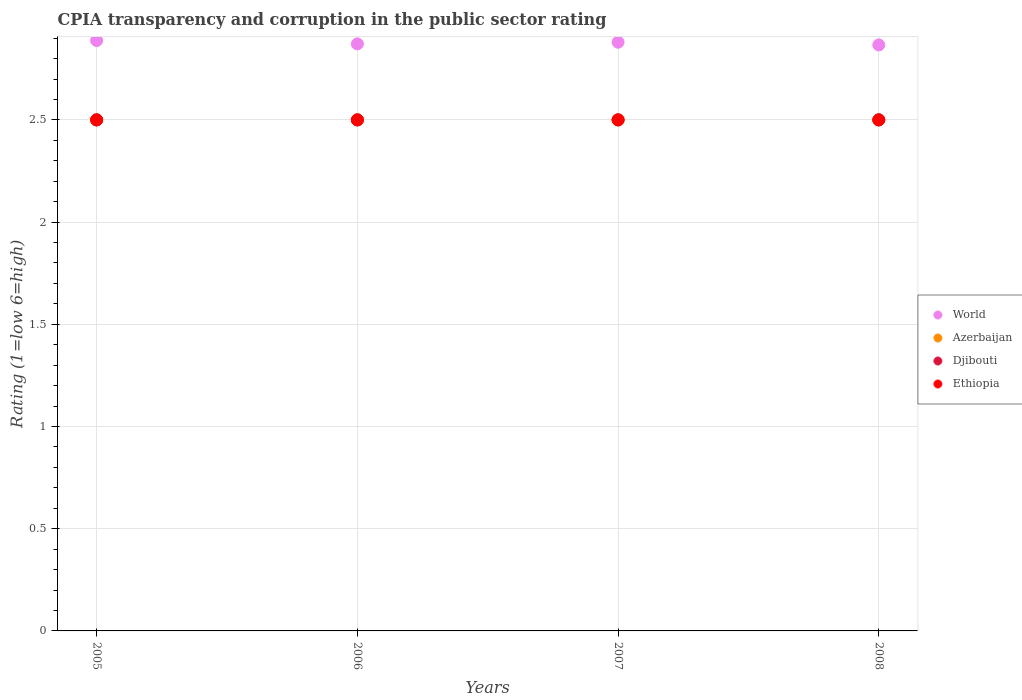How many different coloured dotlines are there?
Keep it short and to the point. 4. Is the number of dotlines equal to the number of legend labels?
Offer a terse response. Yes. What is the CPIA rating in Azerbaijan in 2006?
Your answer should be compact. 2.5. Across all years, what is the minimum CPIA rating in Ethiopia?
Provide a succinct answer. 2.5. In which year was the CPIA rating in Djibouti maximum?
Ensure brevity in your answer.  2005. What is the total CPIA rating in World in the graph?
Provide a short and direct response. 11.51. What is the difference between the CPIA rating in Djibouti in 2005 and that in 2007?
Provide a succinct answer. 0. What is the difference between the CPIA rating in Djibouti in 2005 and the CPIA rating in Ethiopia in 2008?
Offer a very short reply. 0. What is the average CPIA rating in Djibouti per year?
Your response must be concise. 2.5. In the year 2007, what is the difference between the CPIA rating in Ethiopia and CPIA rating in Azerbaijan?
Provide a short and direct response. 0. In how many years, is the CPIA rating in Djibouti greater than 1.6?
Make the answer very short. 4. What is the ratio of the CPIA rating in World in 2005 to that in 2008?
Your response must be concise. 1.01. Is the CPIA rating in World in 2007 less than that in 2008?
Make the answer very short. No. Is the difference between the CPIA rating in Ethiopia in 2006 and 2007 greater than the difference between the CPIA rating in Azerbaijan in 2006 and 2007?
Ensure brevity in your answer.  No. What is the difference between the highest and the lowest CPIA rating in Azerbaijan?
Ensure brevity in your answer.  0. In how many years, is the CPIA rating in World greater than the average CPIA rating in World taken over all years?
Provide a short and direct response. 2. Is the sum of the CPIA rating in Ethiopia in 2007 and 2008 greater than the maximum CPIA rating in World across all years?
Your answer should be very brief. Yes. Is it the case that in every year, the sum of the CPIA rating in Azerbaijan and CPIA rating in World  is greater than the sum of CPIA rating in Ethiopia and CPIA rating in Djibouti?
Your answer should be very brief. Yes. Is it the case that in every year, the sum of the CPIA rating in Azerbaijan and CPIA rating in Ethiopia  is greater than the CPIA rating in Djibouti?
Provide a succinct answer. Yes. Is the CPIA rating in Djibouti strictly less than the CPIA rating in Azerbaijan over the years?
Provide a short and direct response. No. How many dotlines are there?
Keep it short and to the point. 4. Are the values on the major ticks of Y-axis written in scientific E-notation?
Offer a terse response. No. Where does the legend appear in the graph?
Your answer should be compact. Center right. How many legend labels are there?
Offer a terse response. 4. How are the legend labels stacked?
Make the answer very short. Vertical. What is the title of the graph?
Offer a terse response. CPIA transparency and corruption in the public sector rating. Does "Cambodia" appear as one of the legend labels in the graph?
Your response must be concise. No. What is the Rating (1=low 6=high) of World in 2005?
Your answer should be compact. 2.89. What is the Rating (1=low 6=high) in Ethiopia in 2005?
Keep it short and to the point. 2.5. What is the Rating (1=low 6=high) of World in 2006?
Your answer should be compact. 2.87. What is the Rating (1=low 6=high) in Ethiopia in 2006?
Your answer should be compact. 2.5. What is the Rating (1=low 6=high) of World in 2007?
Make the answer very short. 2.88. What is the Rating (1=low 6=high) of Azerbaijan in 2007?
Your response must be concise. 2.5. What is the Rating (1=low 6=high) of Djibouti in 2007?
Your response must be concise. 2.5. What is the Rating (1=low 6=high) of Ethiopia in 2007?
Offer a terse response. 2.5. What is the Rating (1=low 6=high) of World in 2008?
Your answer should be very brief. 2.87. What is the Rating (1=low 6=high) of Azerbaijan in 2008?
Keep it short and to the point. 2.5. Across all years, what is the maximum Rating (1=low 6=high) of World?
Provide a succinct answer. 2.89. Across all years, what is the maximum Rating (1=low 6=high) of Djibouti?
Your response must be concise. 2.5. Across all years, what is the minimum Rating (1=low 6=high) in World?
Ensure brevity in your answer.  2.87. Across all years, what is the minimum Rating (1=low 6=high) in Ethiopia?
Ensure brevity in your answer.  2.5. What is the total Rating (1=low 6=high) of World in the graph?
Offer a terse response. 11.51. What is the total Rating (1=low 6=high) of Ethiopia in the graph?
Keep it short and to the point. 10. What is the difference between the Rating (1=low 6=high) in World in 2005 and that in 2006?
Ensure brevity in your answer.  0.02. What is the difference between the Rating (1=low 6=high) in Ethiopia in 2005 and that in 2006?
Keep it short and to the point. 0. What is the difference between the Rating (1=low 6=high) of World in 2005 and that in 2007?
Make the answer very short. 0.01. What is the difference between the Rating (1=low 6=high) in Azerbaijan in 2005 and that in 2007?
Your response must be concise. 0. What is the difference between the Rating (1=low 6=high) in World in 2005 and that in 2008?
Keep it short and to the point. 0.02. What is the difference between the Rating (1=low 6=high) of World in 2006 and that in 2007?
Give a very brief answer. -0.01. What is the difference between the Rating (1=low 6=high) of Azerbaijan in 2006 and that in 2007?
Keep it short and to the point. 0. What is the difference between the Rating (1=low 6=high) in Djibouti in 2006 and that in 2007?
Give a very brief answer. 0. What is the difference between the Rating (1=low 6=high) in World in 2006 and that in 2008?
Provide a succinct answer. 0.01. What is the difference between the Rating (1=low 6=high) in World in 2007 and that in 2008?
Ensure brevity in your answer.  0.01. What is the difference between the Rating (1=low 6=high) in Ethiopia in 2007 and that in 2008?
Make the answer very short. 0. What is the difference between the Rating (1=low 6=high) in World in 2005 and the Rating (1=low 6=high) in Azerbaijan in 2006?
Offer a terse response. 0.39. What is the difference between the Rating (1=low 6=high) of World in 2005 and the Rating (1=low 6=high) of Djibouti in 2006?
Your answer should be compact. 0.39. What is the difference between the Rating (1=low 6=high) of World in 2005 and the Rating (1=low 6=high) of Ethiopia in 2006?
Your answer should be very brief. 0.39. What is the difference between the Rating (1=low 6=high) of Azerbaijan in 2005 and the Rating (1=low 6=high) of Djibouti in 2006?
Provide a succinct answer. 0. What is the difference between the Rating (1=low 6=high) of Azerbaijan in 2005 and the Rating (1=low 6=high) of Ethiopia in 2006?
Keep it short and to the point. 0. What is the difference between the Rating (1=low 6=high) of World in 2005 and the Rating (1=low 6=high) of Azerbaijan in 2007?
Provide a short and direct response. 0.39. What is the difference between the Rating (1=low 6=high) in World in 2005 and the Rating (1=low 6=high) in Djibouti in 2007?
Keep it short and to the point. 0.39. What is the difference between the Rating (1=low 6=high) in World in 2005 and the Rating (1=low 6=high) in Ethiopia in 2007?
Offer a very short reply. 0.39. What is the difference between the Rating (1=low 6=high) in Djibouti in 2005 and the Rating (1=low 6=high) in Ethiopia in 2007?
Offer a terse response. 0. What is the difference between the Rating (1=low 6=high) in World in 2005 and the Rating (1=low 6=high) in Azerbaijan in 2008?
Provide a succinct answer. 0.39. What is the difference between the Rating (1=low 6=high) in World in 2005 and the Rating (1=low 6=high) in Djibouti in 2008?
Offer a terse response. 0.39. What is the difference between the Rating (1=low 6=high) of World in 2005 and the Rating (1=low 6=high) of Ethiopia in 2008?
Ensure brevity in your answer.  0.39. What is the difference between the Rating (1=low 6=high) in Azerbaijan in 2005 and the Rating (1=low 6=high) in Ethiopia in 2008?
Provide a succinct answer. 0. What is the difference between the Rating (1=low 6=high) in World in 2006 and the Rating (1=low 6=high) in Azerbaijan in 2007?
Provide a succinct answer. 0.37. What is the difference between the Rating (1=low 6=high) of World in 2006 and the Rating (1=low 6=high) of Djibouti in 2007?
Ensure brevity in your answer.  0.37. What is the difference between the Rating (1=low 6=high) in World in 2006 and the Rating (1=low 6=high) in Ethiopia in 2007?
Keep it short and to the point. 0.37. What is the difference between the Rating (1=low 6=high) of World in 2006 and the Rating (1=low 6=high) of Azerbaijan in 2008?
Make the answer very short. 0.37. What is the difference between the Rating (1=low 6=high) in World in 2006 and the Rating (1=low 6=high) in Djibouti in 2008?
Your response must be concise. 0.37. What is the difference between the Rating (1=low 6=high) in World in 2006 and the Rating (1=low 6=high) in Ethiopia in 2008?
Offer a terse response. 0.37. What is the difference between the Rating (1=low 6=high) in Azerbaijan in 2006 and the Rating (1=low 6=high) in Djibouti in 2008?
Offer a terse response. 0. What is the difference between the Rating (1=low 6=high) of Djibouti in 2006 and the Rating (1=low 6=high) of Ethiopia in 2008?
Your answer should be compact. 0. What is the difference between the Rating (1=low 6=high) of World in 2007 and the Rating (1=low 6=high) of Azerbaijan in 2008?
Make the answer very short. 0.38. What is the difference between the Rating (1=low 6=high) of World in 2007 and the Rating (1=low 6=high) of Djibouti in 2008?
Ensure brevity in your answer.  0.38. What is the difference between the Rating (1=low 6=high) in World in 2007 and the Rating (1=low 6=high) in Ethiopia in 2008?
Give a very brief answer. 0.38. What is the difference between the Rating (1=low 6=high) in Azerbaijan in 2007 and the Rating (1=low 6=high) in Djibouti in 2008?
Provide a succinct answer. 0. What is the difference between the Rating (1=low 6=high) of Djibouti in 2007 and the Rating (1=low 6=high) of Ethiopia in 2008?
Make the answer very short. 0. What is the average Rating (1=low 6=high) in World per year?
Keep it short and to the point. 2.88. What is the average Rating (1=low 6=high) in Azerbaijan per year?
Keep it short and to the point. 2.5. What is the average Rating (1=low 6=high) of Djibouti per year?
Your answer should be compact. 2.5. What is the average Rating (1=low 6=high) in Ethiopia per year?
Give a very brief answer. 2.5. In the year 2005, what is the difference between the Rating (1=low 6=high) of World and Rating (1=low 6=high) of Azerbaijan?
Ensure brevity in your answer.  0.39. In the year 2005, what is the difference between the Rating (1=low 6=high) of World and Rating (1=low 6=high) of Djibouti?
Offer a very short reply. 0.39. In the year 2005, what is the difference between the Rating (1=low 6=high) of World and Rating (1=low 6=high) of Ethiopia?
Provide a short and direct response. 0.39. In the year 2005, what is the difference between the Rating (1=low 6=high) of Azerbaijan and Rating (1=low 6=high) of Djibouti?
Keep it short and to the point. 0. In the year 2005, what is the difference between the Rating (1=low 6=high) in Azerbaijan and Rating (1=low 6=high) in Ethiopia?
Provide a succinct answer. 0. In the year 2006, what is the difference between the Rating (1=low 6=high) of World and Rating (1=low 6=high) of Azerbaijan?
Make the answer very short. 0.37. In the year 2006, what is the difference between the Rating (1=low 6=high) in World and Rating (1=low 6=high) in Djibouti?
Your answer should be compact. 0.37. In the year 2006, what is the difference between the Rating (1=low 6=high) in World and Rating (1=low 6=high) in Ethiopia?
Your answer should be compact. 0.37. In the year 2006, what is the difference between the Rating (1=low 6=high) in Djibouti and Rating (1=low 6=high) in Ethiopia?
Offer a terse response. 0. In the year 2007, what is the difference between the Rating (1=low 6=high) in World and Rating (1=low 6=high) in Azerbaijan?
Offer a terse response. 0.38. In the year 2007, what is the difference between the Rating (1=low 6=high) in World and Rating (1=low 6=high) in Djibouti?
Provide a succinct answer. 0.38. In the year 2007, what is the difference between the Rating (1=low 6=high) in World and Rating (1=low 6=high) in Ethiopia?
Your response must be concise. 0.38. In the year 2007, what is the difference between the Rating (1=low 6=high) in Djibouti and Rating (1=low 6=high) in Ethiopia?
Offer a very short reply. 0. In the year 2008, what is the difference between the Rating (1=low 6=high) of World and Rating (1=low 6=high) of Azerbaijan?
Your response must be concise. 0.37. In the year 2008, what is the difference between the Rating (1=low 6=high) in World and Rating (1=low 6=high) in Djibouti?
Your answer should be compact. 0.37. In the year 2008, what is the difference between the Rating (1=low 6=high) of World and Rating (1=low 6=high) of Ethiopia?
Ensure brevity in your answer.  0.37. In the year 2008, what is the difference between the Rating (1=low 6=high) of Azerbaijan and Rating (1=low 6=high) of Djibouti?
Give a very brief answer. 0. In the year 2008, what is the difference between the Rating (1=low 6=high) of Azerbaijan and Rating (1=low 6=high) of Ethiopia?
Provide a succinct answer. 0. What is the ratio of the Rating (1=low 6=high) of Azerbaijan in 2005 to that in 2006?
Keep it short and to the point. 1. What is the ratio of the Rating (1=low 6=high) in Djibouti in 2005 to that in 2006?
Keep it short and to the point. 1. What is the ratio of the Rating (1=low 6=high) in Ethiopia in 2005 to that in 2006?
Make the answer very short. 1. What is the ratio of the Rating (1=low 6=high) in Djibouti in 2005 to that in 2007?
Ensure brevity in your answer.  1. What is the ratio of the Rating (1=low 6=high) of World in 2005 to that in 2008?
Make the answer very short. 1.01. What is the ratio of the Rating (1=low 6=high) of Djibouti in 2005 to that in 2008?
Your response must be concise. 1. What is the ratio of the Rating (1=low 6=high) of World in 2006 to that in 2007?
Offer a very short reply. 1. What is the ratio of the Rating (1=low 6=high) in Azerbaijan in 2006 to that in 2007?
Your answer should be compact. 1. What is the ratio of the Rating (1=low 6=high) in Djibouti in 2006 to that in 2007?
Your answer should be compact. 1. What is the ratio of the Rating (1=low 6=high) of World in 2007 to that in 2008?
Ensure brevity in your answer.  1. What is the ratio of the Rating (1=low 6=high) in Azerbaijan in 2007 to that in 2008?
Provide a succinct answer. 1. What is the difference between the highest and the second highest Rating (1=low 6=high) of World?
Make the answer very short. 0.01. What is the difference between the highest and the second highest Rating (1=low 6=high) in Azerbaijan?
Provide a short and direct response. 0. What is the difference between the highest and the second highest Rating (1=low 6=high) in Ethiopia?
Give a very brief answer. 0. What is the difference between the highest and the lowest Rating (1=low 6=high) of World?
Offer a very short reply. 0.02. What is the difference between the highest and the lowest Rating (1=low 6=high) in Azerbaijan?
Give a very brief answer. 0. What is the difference between the highest and the lowest Rating (1=low 6=high) of Djibouti?
Keep it short and to the point. 0. 